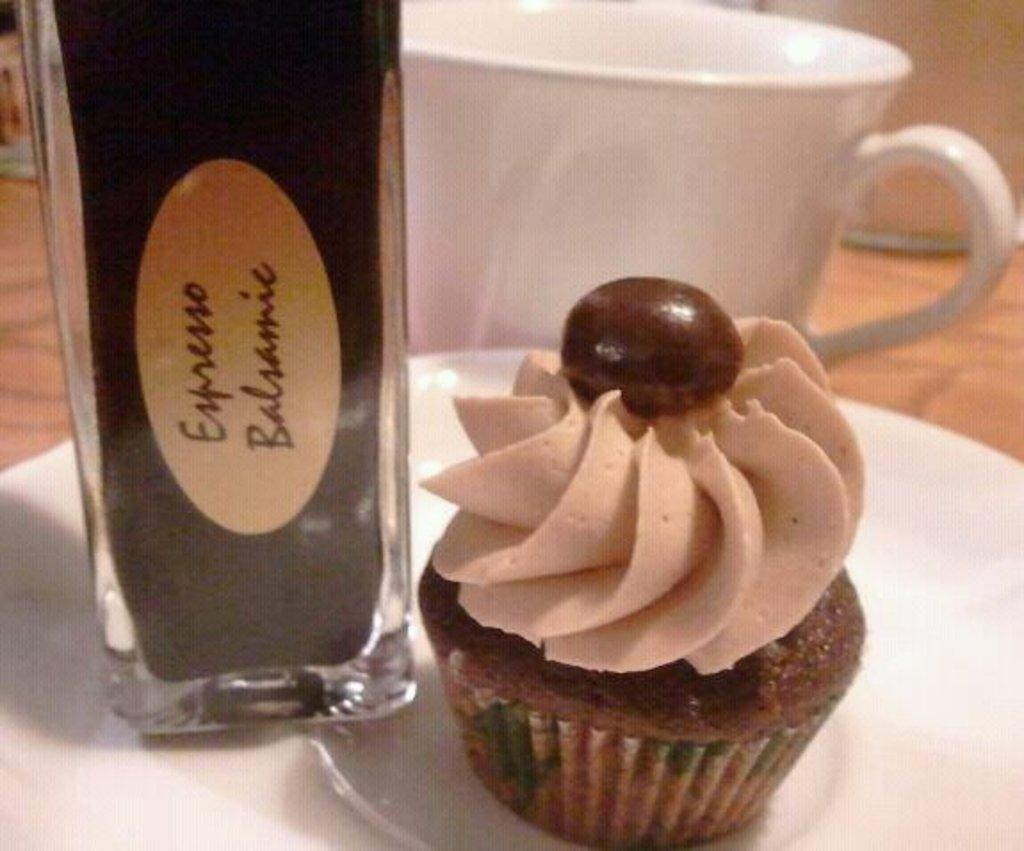<image>
Render a clear and concise summary of the photo. A cupcakes next to a brown bottle that says Espresso on it sitting on a plate. 